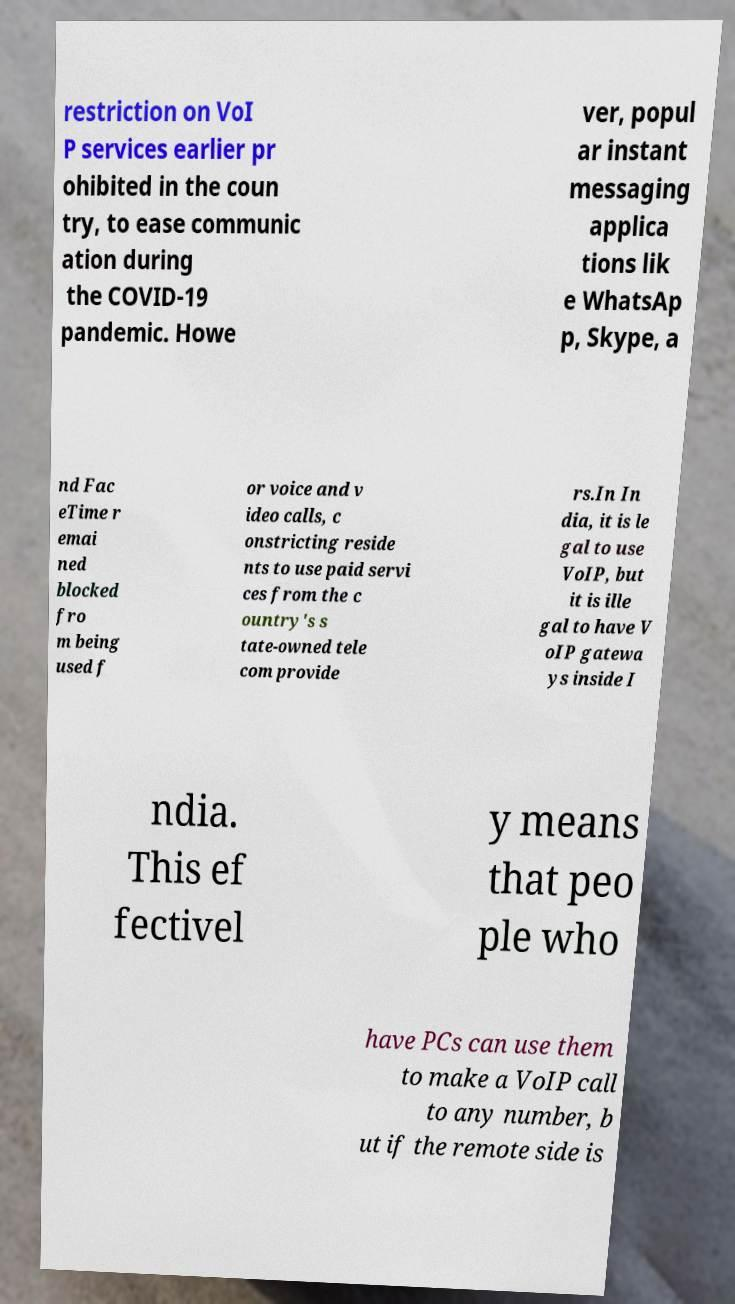Please identify and transcribe the text found in this image. restriction on VoI P services earlier pr ohibited in the coun try, to ease communic ation during the COVID-19 pandemic. Howe ver, popul ar instant messaging applica tions lik e WhatsAp p, Skype, a nd Fac eTime r emai ned blocked fro m being used f or voice and v ideo calls, c onstricting reside nts to use paid servi ces from the c ountry's s tate-owned tele com provide rs.In In dia, it is le gal to use VoIP, but it is ille gal to have V oIP gatewa ys inside I ndia. This ef fectivel y means that peo ple who have PCs can use them to make a VoIP call to any number, b ut if the remote side is 